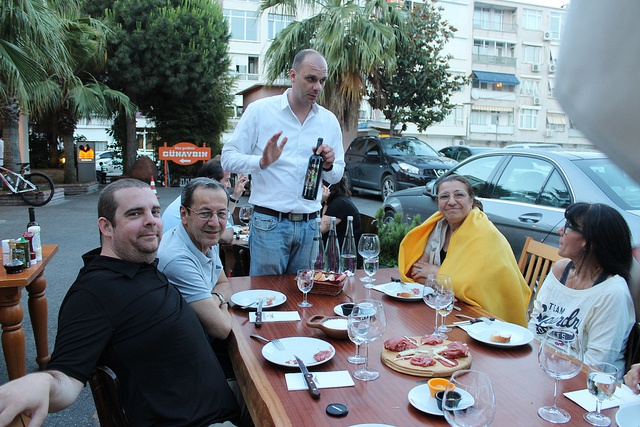Describe the objects in this image and their specific colors. I can see dining table in teal, darkgray, lightblue, and brown tones, people in teal, black, darkgray, and gray tones, people in teal, lightblue, and gray tones, car in teal, lightblue, gray, and blue tones, and people in teal, black, lightblue, and darkgray tones in this image. 